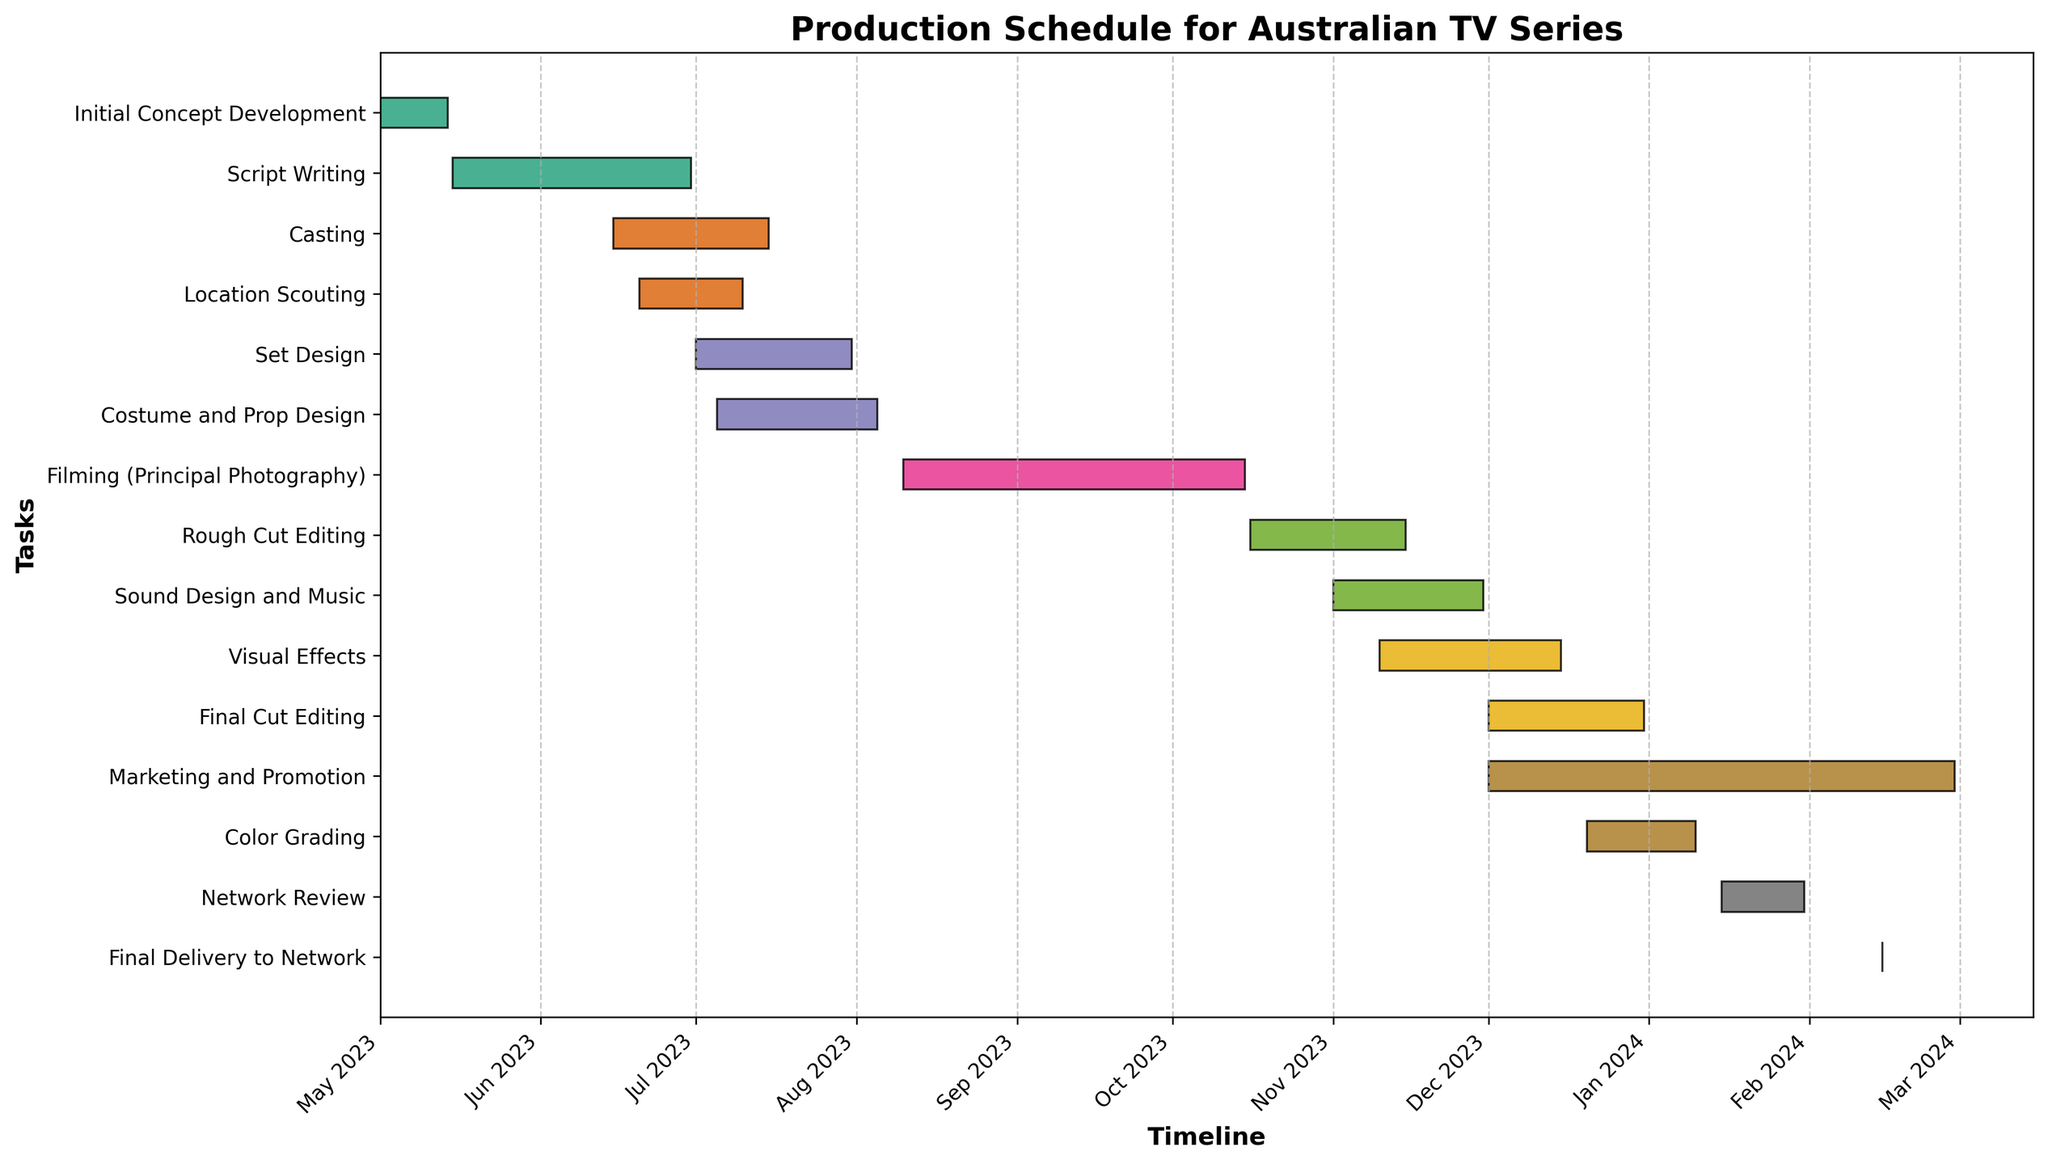What is the title of the Gantt chart? The title is usually found at the top of the chart and describes what the chart is about. In this case, it is clearly stated at the top of the figure.
Answer: Production Schedule for Australian TV Series How many tasks are there in the entire production schedule? Count the number of horizontal bars (tasks) listed on the y-axis.
Answer: 14 What is the earliest starting task and when does it start? The earliest starting task can be identified as the one with the leftmost bar. Check the x-axis date where this task starts.
Answer: Initial Concept Development, 2023-05-01 Which tasks overlap with the Filming (Principal Photography) phase? Examine the dates on the x-axis for the Filming task and identify any other tasks whose bars overlap with these dates.
Answer: Rough Cut Editing, Sound Design and Music, Visual Effects How long is the Script Writing phase? The length of a task can be calculated by the number of days between its start and end dates.
Answer: 46 days What is the shortest task in the schedule and how long does it last? Find the task with the smallest horizontal bar and count the days from its start to end date.
Answer: Final Delivery to Network, 1 day Among the tasks that are in progress during December 2023, which one finishes first? Identify tasks active in December 2023 by their overlap with this period on the x-axis and note the one with the earliest end date within this month.
Answer: Rough Cut Editing, 2023-11-15 Which task has the same start date as the Network Review? Look for the task bar(s) that start on the same date as the Network Review task on the x-axis.
Answer: Final Delivery to Network Between Set Design and Costume and Prop Design, which starts later and by how many days? Compare the start dates of Set Design and Costume and Prop Design and calculate the difference in days.
Answer: Costume and Prop Design starts later by 4 days (2023-07-05 vs. 2023-07-01) What is the average duration of all tasks in the schedule? Sum the durations of all tasks and divide by the number of tasks to find the average.
Answer: 34 days 